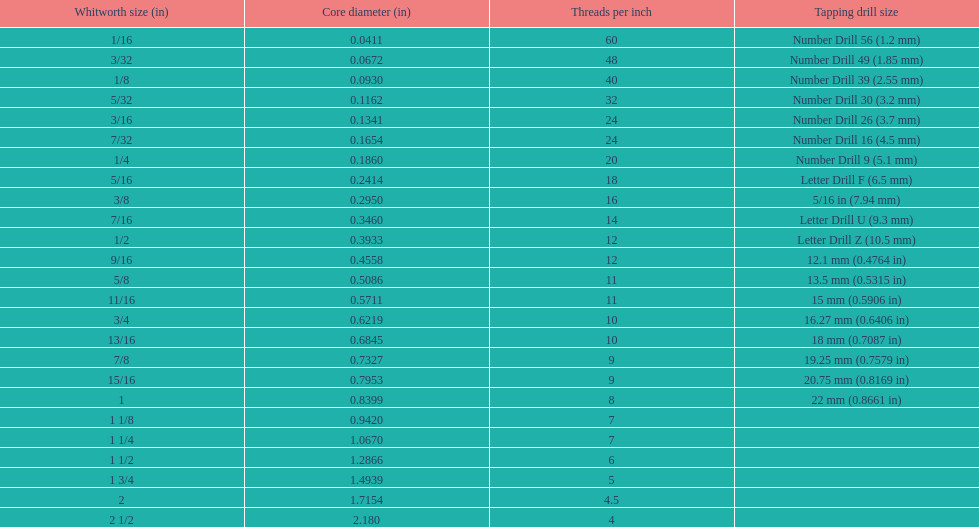What is the core diameter of the last whitworth thread size? 2.180. 